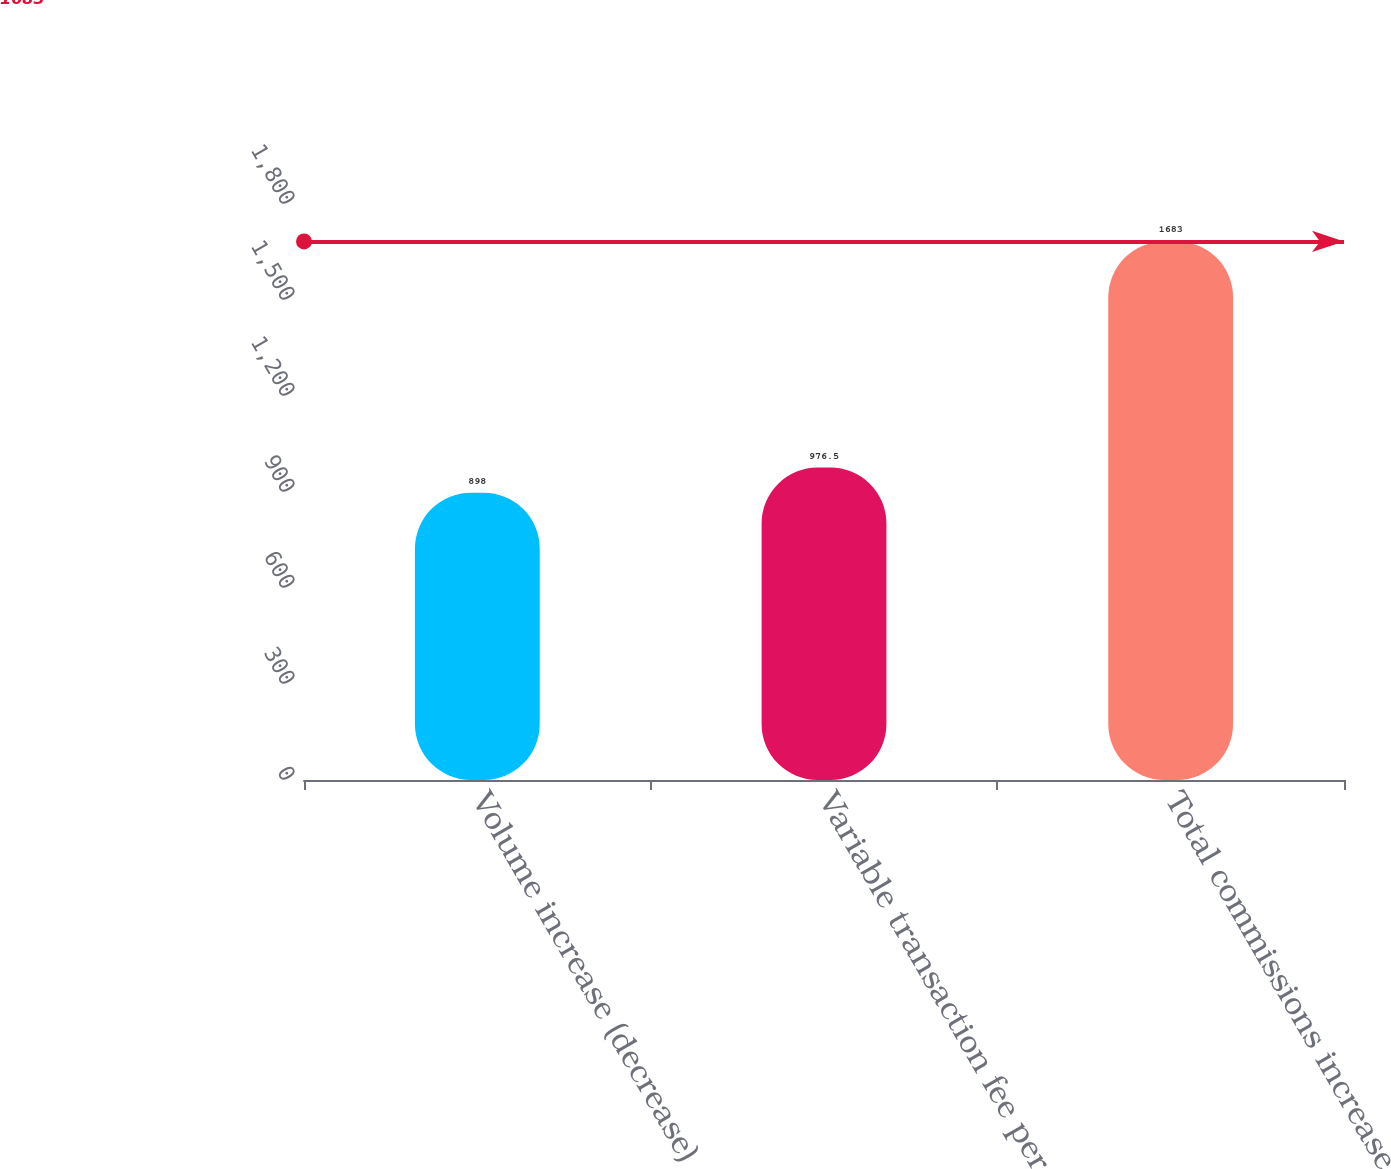<chart> <loc_0><loc_0><loc_500><loc_500><bar_chart><fcel>Volume increase (decrease)<fcel>Variable transaction fee per<fcel>Total commissions increase<nl><fcel>898<fcel>976.5<fcel>1683<nl></chart> 